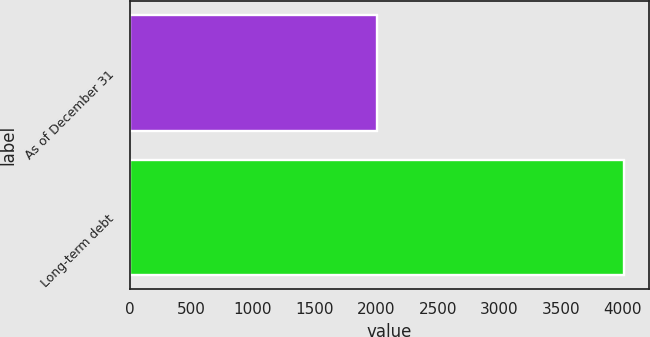Convert chart to OTSL. <chart><loc_0><loc_0><loc_500><loc_500><bar_chart><fcel>As of December 31<fcel>Long-term debt<nl><fcel>2010<fcel>4014<nl></chart> 